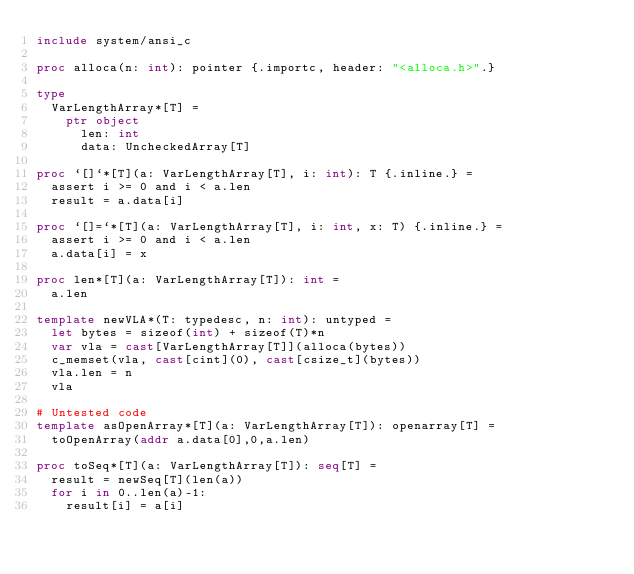Convert code to text. <code><loc_0><loc_0><loc_500><loc_500><_Nim_>include system/ansi_c

proc alloca(n: int): pointer {.importc, header: "<alloca.h>".}

type
  VarLengthArray*[T] =
    ptr object
      len: int
      data: UncheckedArray[T]

proc `[]`*[T](a: VarLengthArray[T], i: int): T {.inline.} =
  assert i >= 0 and i < a.len
  result = a.data[i]

proc `[]=`*[T](a: VarLengthArray[T], i: int, x: T) {.inline.} =
  assert i >= 0 and i < a.len
  a.data[i] = x

proc len*[T](a: VarLengthArray[T]): int =
  a.len

template newVLA*(T: typedesc, n: int): untyped =
  let bytes = sizeof(int) + sizeof(T)*n
  var vla = cast[VarLengthArray[T]](alloca(bytes))
  c_memset(vla, cast[cint](0), cast[csize_t](bytes))
  vla.len = n
  vla

# Untested code
template asOpenArray*[T](a: VarLengthArray[T]): openarray[T] =
  toOpenArray(addr a.data[0],0,a.len)

proc toSeq*[T](a: VarLengthArray[T]): seq[T] =
  result = newSeq[T](len(a))
  for i in 0..len(a)-1:
    result[i] = a[i]
</code> 